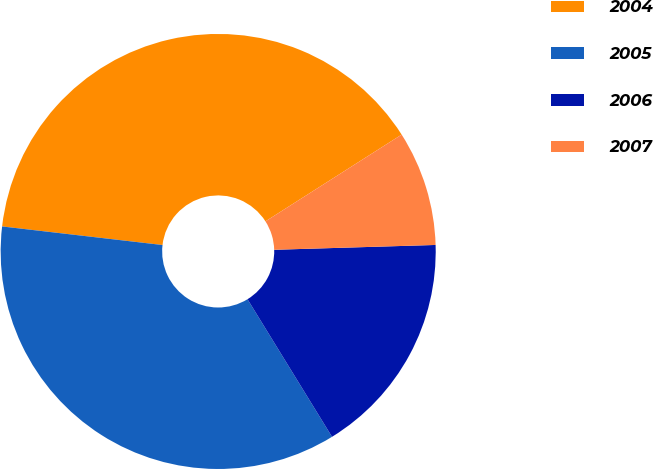Convert chart. <chart><loc_0><loc_0><loc_500><loc_500><pie_chart><fcel>2004<fcel>2005<fcel>2006<fcel>2007<nl><fcel>39.14%<fcel>35.6%<fcel>16.71%<fcel>8.55%<nl></chart> 